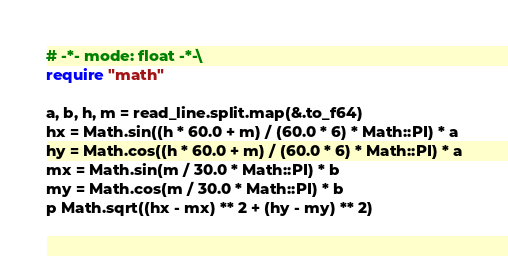Convert code to text. <code><loc_0><loc_0><loc_500><loc_500><_Crystal_># -*- mode: float -*-\
require "math"

a, b, h, m = read_line.split.map(&.to_f64)
hx = Math.sin((h * 60.0 + m) / (60.0 * 6) * Math::PI) * a
hy = Math.cos((h * 60.0 + m) / (60.0 * 6) * Math::PI) * a
mx = Math.sin(m / 30.0 * Math::PI) * b
my = Math.cos(m / 30.0 * Math::PI) * b
p Math.sqrt((hx - mx) ** 2 + (hy - my) ** 2)
</code> 